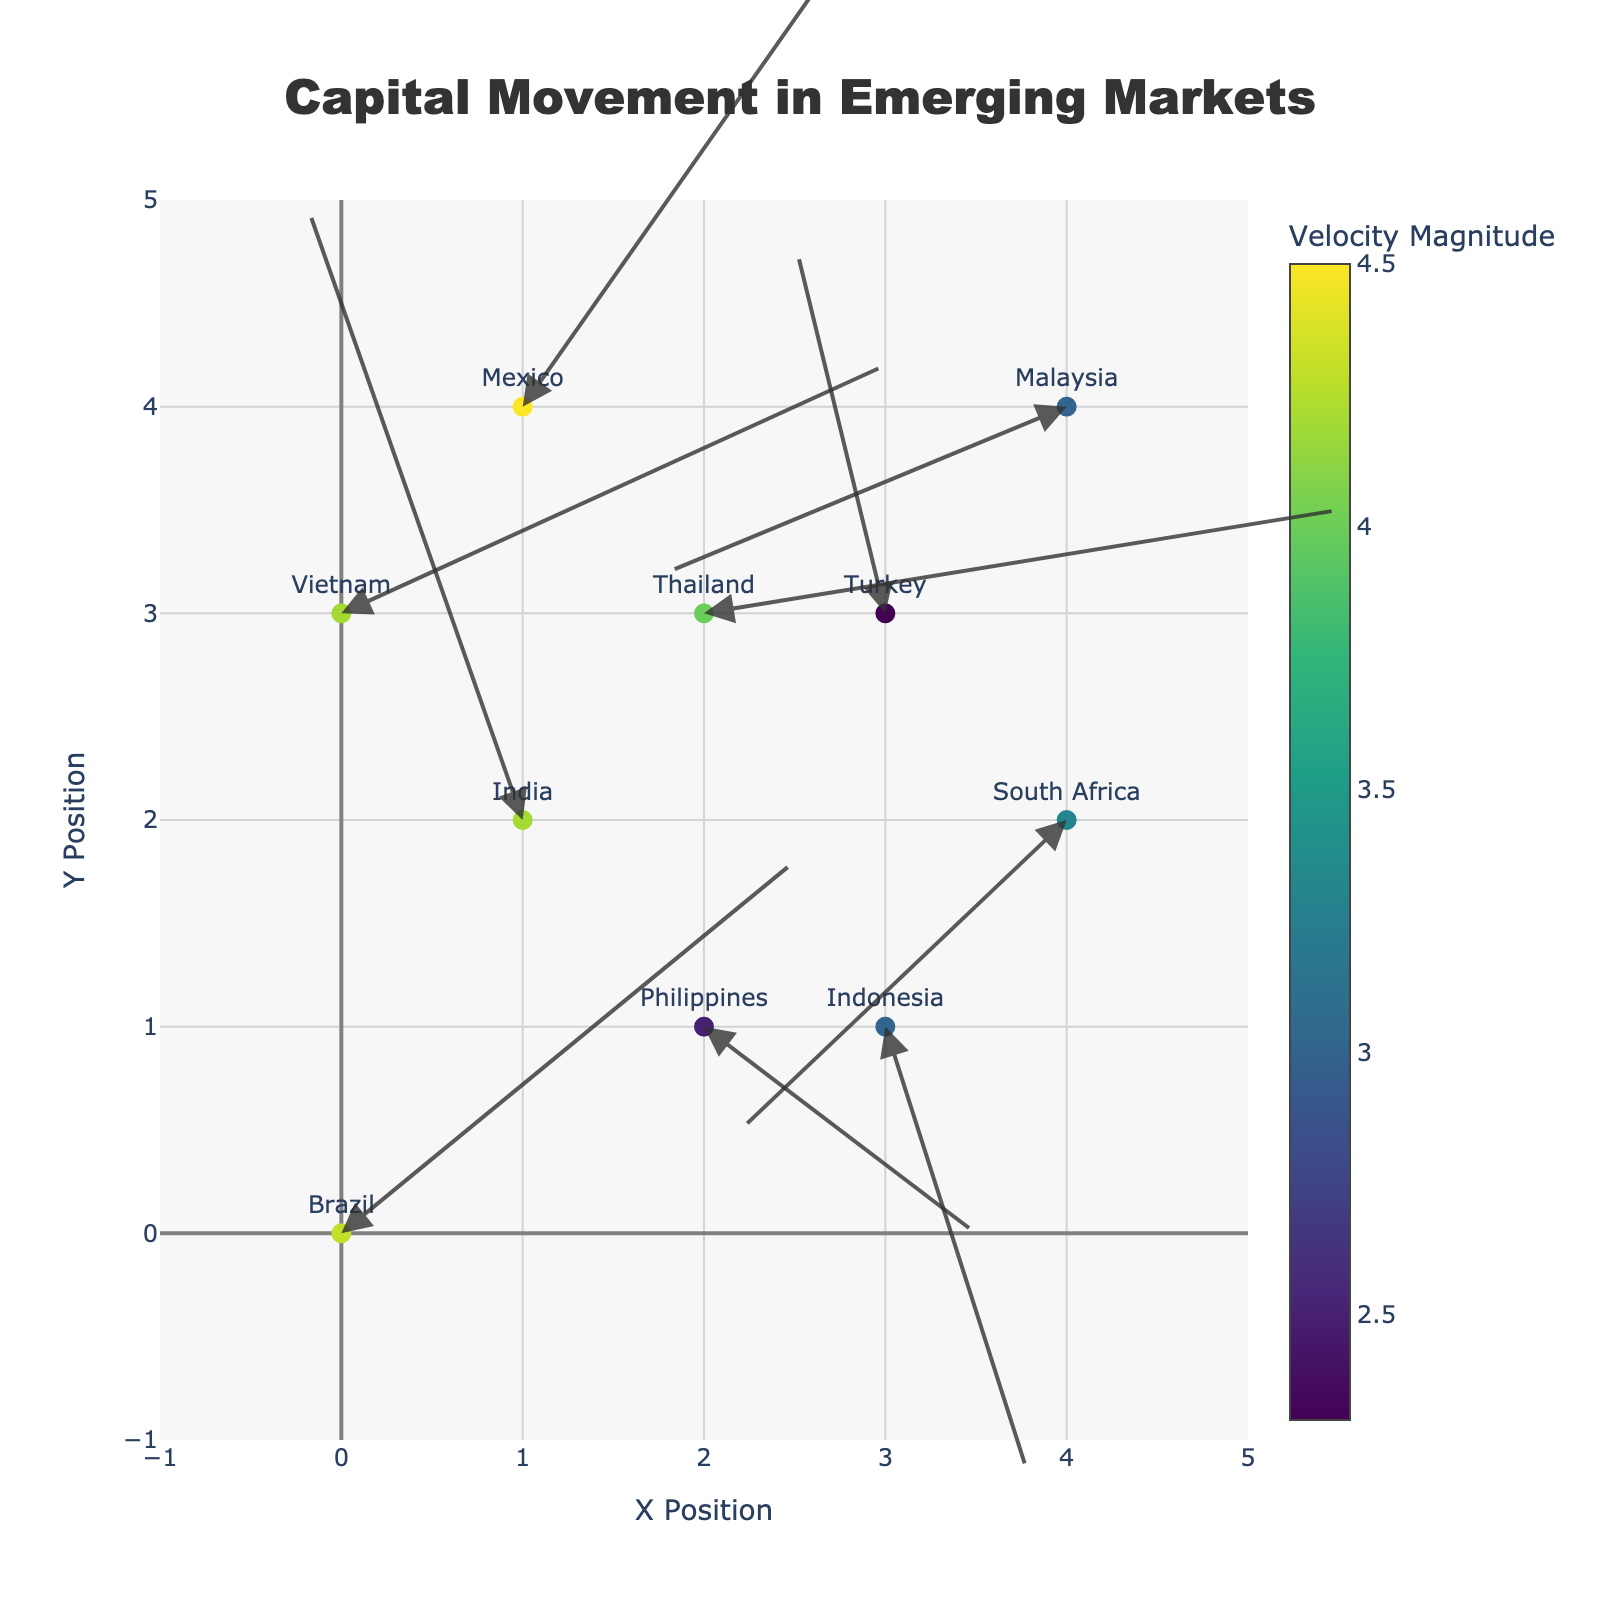What's the title of the figure? The title is located at the top center of the figure. It gives a brief overview of what the figure is about. Here, the title is "Capital Movement in Emerging Markets".
Answer: Capital Movement in Emerging Markets How many emerging markets (countries) are represented in the plot? Count each unique country label on the plot. The countries mentioned are Brazil, India, Indonesia, Thailand, South Africa, Mexico, Turkey, Philippines, Malaysia, and Vietnam.
Answer: 10 Which country shows the highest velocity magnitude of capital movement? The velocity magnitude is represented by the sum of the absolute values of U and V. Checking each country: Brazil (4.3), India (4.2), Indonesia (3.0), Thailand (4.0), South Africa (3.3), Mexico (4.5), Turkey (2.3), Philippines (2.5), Malaysia (3.0), Vietnam (4.2). Mexico has the highest value.
Answer: Mexico What is the direction of capital movement in Indonesia? The direction corresponds to the U and V components. For Indonesia, U is 0.8 and V is -2.2, indicating capital movement slightly right (east) and downward (south).
Answer: Slightly right and downward Are any two countries showing capital movement in the exact same direction? The direction (U, V) needs to be compared for all pairs of countries. The values of U and V for each country are unique in this dataset, so no two countries have the same direction of capital movement.
Answer: No Which country has the most negative U component? Examine the U values of all countries. The most negative U component is found in Malaysia with U = -2.2.
Answer: Malaysia How are the color of the markers decided in this plot? Refer to the color legend; it is based on the velocity magnitude calculated by adding the absolute values of U and V. The total movement determines the color intensity.
Answer: Velocity magnitude Which countries have a positive Y component in their capital movement direction? Check the V values for each country: Brazil (1.8), India (3.0), Thailand (0.5), Mexico (2.5), Turkey (1.8), and Vietnam (1.2) all have positive Y components.
Answer: Brazil, India, Thailand, Mexico, Turkey, Vietnam Where do we see the strongest negative Y component in capital movement direction? Search for the lowest V value among the countries. The lowest V value is Indonesia with V = -2.2.
Answer: Indonesia 